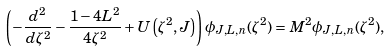Convert formula to latex. <formula><loc_0><loc_0><loc_500><loc_500>\left ( - \frac { d ^ { 2 } } { d \zeta ^ { 2 } } - \frac { 1 - 4 L ^ { 2 } } { 4 \zeta ^ { 2 } } + U \left ( \zeta ^ { 2 } , J \right ) \right ) \phi _ { J , L , n } ( \zeta ^ { 2 } ) = M ^ { 2 } \phi _ { J , L , n } ( \zeta ^ { 2 } ) ,</formula> 